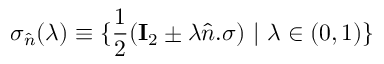<formula> <loc_0><loc_0><loc_500><loc_500>\sigma _ { \hat { n } } ( \lambda ) \equiv \{ \frac { 1 } { 2 } ( I _ { 2 } \pm \lambda \hat { n } . \sigma ) | \lambda \in ( 0 , 1 ) \}</formula> 